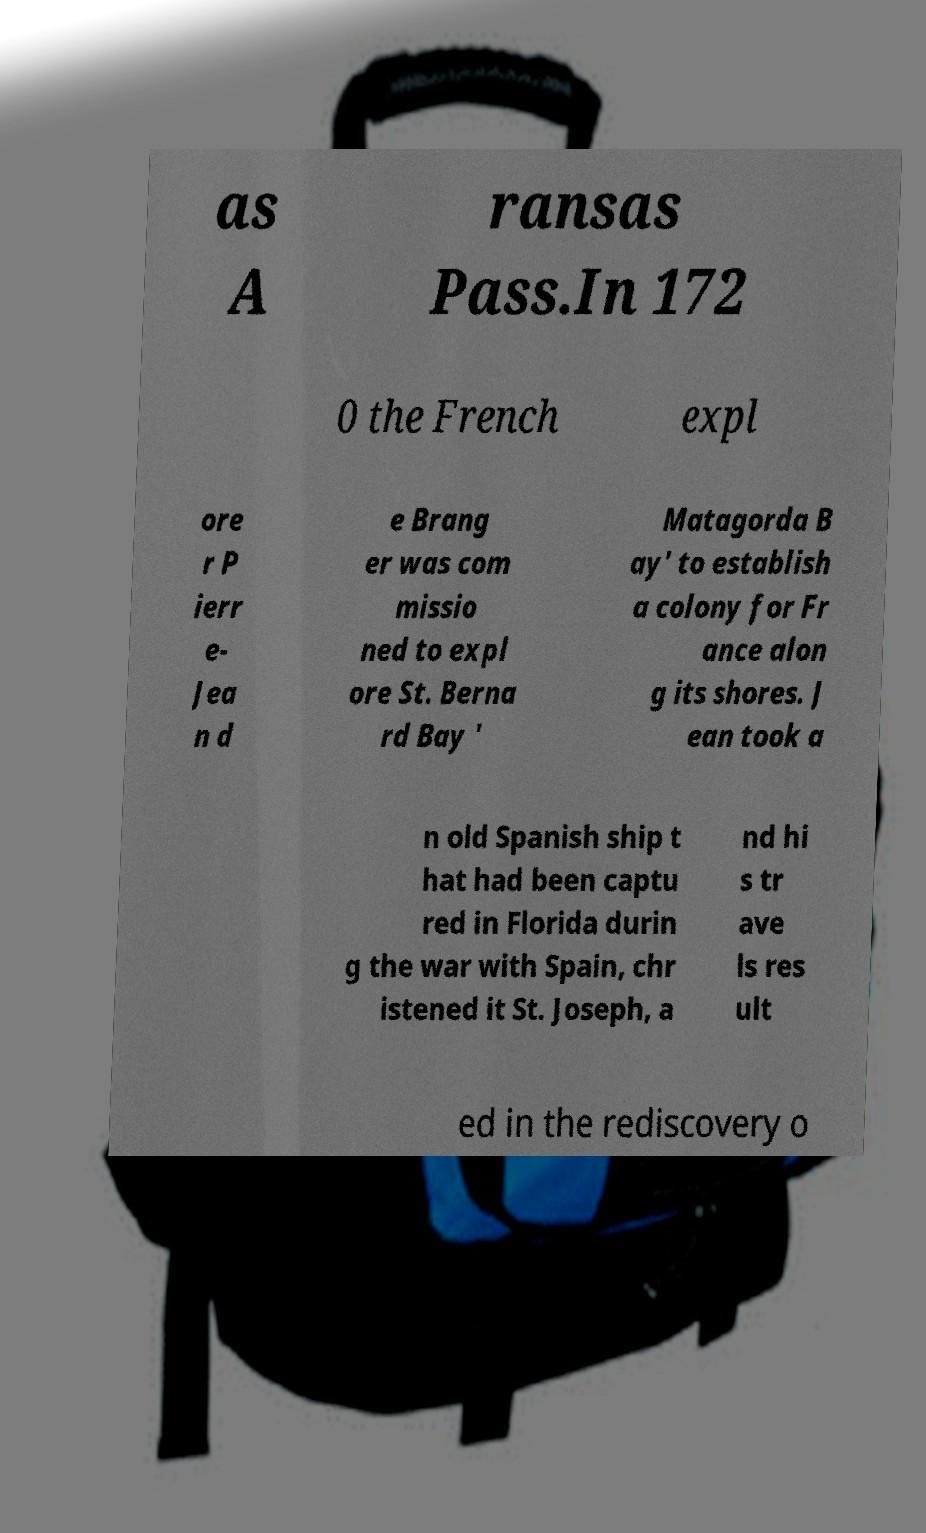I need the written content from this picture converted into text. Can you do that? as A ransas Pass.In 172 0 the French expl ore r P ierr e- Jea n d e Brang er was com missio ned to expl ore St. Berna rd Bay ' Matagorda B ay' to establish a colony for Fr ance alon g its shores. J ean took a n old Spanish ship t hat had been captu red in Florida durin g the war with Spain, chr istened it St. Joseph, a nd hi s tr ave ls res ult ed in the rediscovery o 